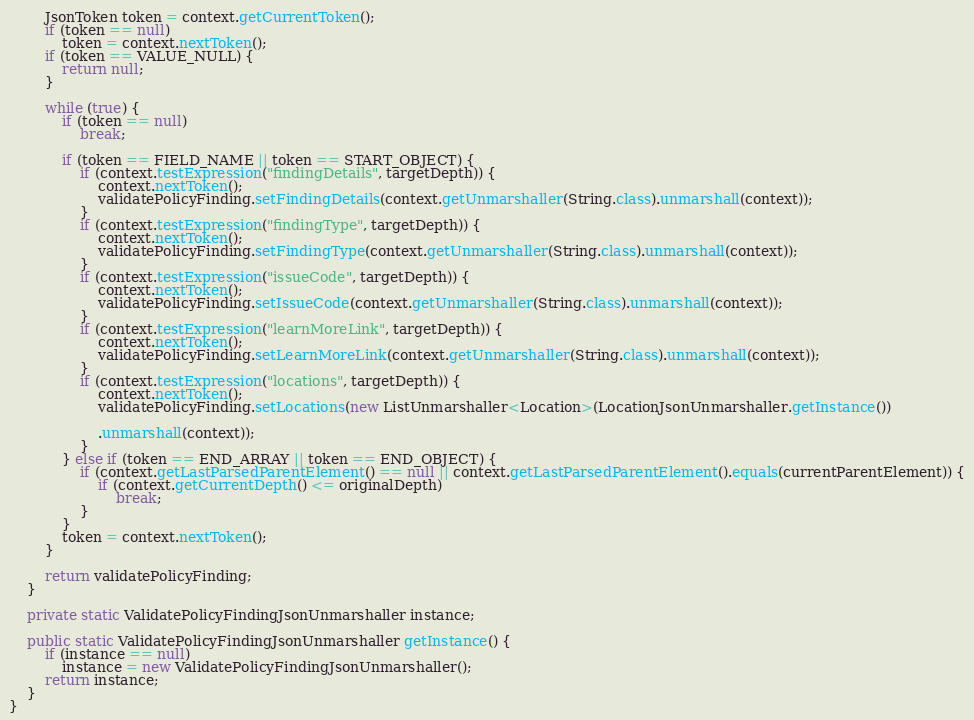<code> <loc_0><loc_0><loc_500><loc_500><_Java_>
        JsonToken token = context.getCurrentToken();
        if (token == null)
            token = context.nextToken();
        if (token == VALUE_NULL) {
            return null;
        }

        while (true) {
            if (token == null)
                break;

            if (token == FIELD_NAME || token == START_OBJECT) {
                if (context.testExpression("findingDetails", targetDepth)) {
                    context.nextToken();
                    validatePolicyFinding.setFindingDetails(context.getUnmarshaller(String.class).unmarshall(context));
                }
                if (context.testExpression("findingType", targetDepth)) {
                    context.nextToken();
                    validatePolicyFinding.setFindingType(context.getUnmarshaller(String.class).unmarshall(context));
                }
                if (context.testExpression("issueCode", targetDepth)) {
                    context.nextToken();
                    validatePolicyFinding.setIssueCode(context.getUnmarshaller(String.class).unmarshall(context));
                }
                if (context.testExpression("learnMoreLink", targetDepth)) {
                    context.nextToken();
                    validatePolicyFinding.setLearnMoreLink(context.getUnmarshaller(String.class).unmarshall(context));
                }
                if (context.testExpression("locations", targetDepth)) {
                    context.nextToken();
                    validatePolicyFinding.setLocations(new ListUnmarshaller<Location>(LocationJsonUnmarshaller.getInstance())

                    .unmarshall(context));
                }
            } else if (token == END_ARRAY || token == END_OBJECT) {
                if (context.getLastParsedParentElement() == null || context.getLastParsedParentElement().equals(currentParentElement)) {
                    if (context.getCurrentDepth() <= originalDepth)
                        break;
                }
            }
            token = context.nextToken();
        }

        return validatePolicyFinding;
    }

    private static ValidatePolicyFindingJsonUnmarshaller instance;

    public static ValidatePolicyFindingJsonUnmarshaller getInstance() {
        if (instance == null)
            instance = new ValidatePolicyFindingJsonUnmarshaller();
        return instance;
    }
}
</code> 